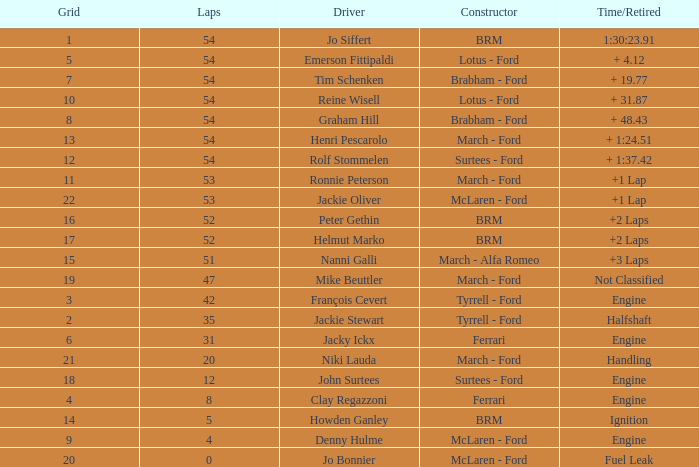What is the low grid that has brm and over 54 laps? None. 